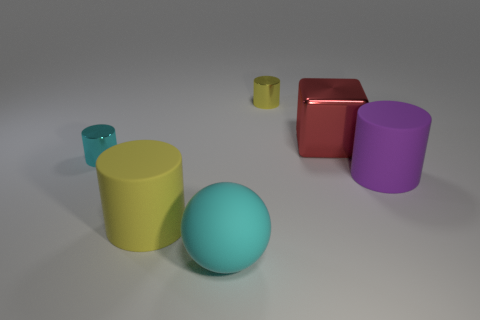There is a tiny object that is the same color as the rubber ball; what is it made of?
Offer a very short reply. Metal. There is a metallic object that is on the left side of the block and right of the matte ball; what size is it?
Your answer should be very brief. Small. The cylinder that is in front of the small yellow cylinder and to the right of the big cyan thing is what color?
Your response must be concise. Purple. Are there fewer rubber cylinders that are on the right side of the big yellow rubber thing than small objects that are on the right side of the big sphere?
Your answer should be compact. No. How many big cyan matte things are the same shape as the yellow shiny object?
Offer a terse response. 0. What size is the block that is made of the same material as the small cyan cylinder?
Provide a short and direct response. Large. There is a large matte cylinder that is left of the small cylinder behind the small cyan metal object; what color is it?
Ensure brevity in your answer.  Yellow. There is a big shiny object; is its shape the same as the tiny thing in front of the yellow metallic object?
Keep it short and to the point. No. What number of other rubber spheres are the same size as the rubber ball?
Make the answer very short. 0. There is a tiny yellow object that is the same shape as the small cyan object; what material is it?
Your response must be concise. Metal. 